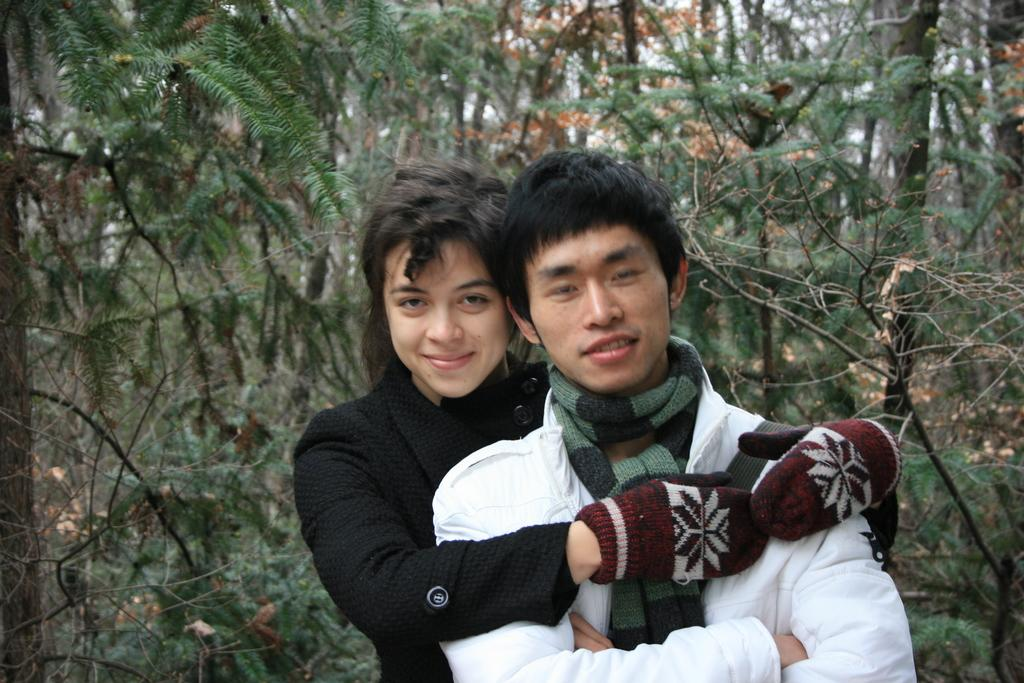How many people are in the image? There are two people in the image. What is the facial expression of the people in the image? The people are smiling. What can be seen in the background of the image? There are trees visible in the background of the image. How many lizards are crawling on the people's faces in the image? There are no lizards present in the image. What type of nail is being used by one of the people in the image? There is no nail visible in the image. 